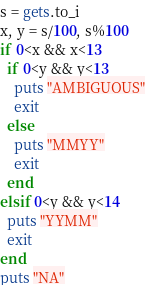<code> <loc_0><loc_0><loc_500><loc_500><_Ruby_>s = gets.to_i
x, y = s/100, s%100
if 0<x && x<13
  if 0<y && y<13
    puts "AMBIGUOUS"
    exit
  else
    puts "MMYY"
    exit
  end
elsif 0<y && y<14
  puts "YYMM"
  exit
end
puts "NA"</code> 